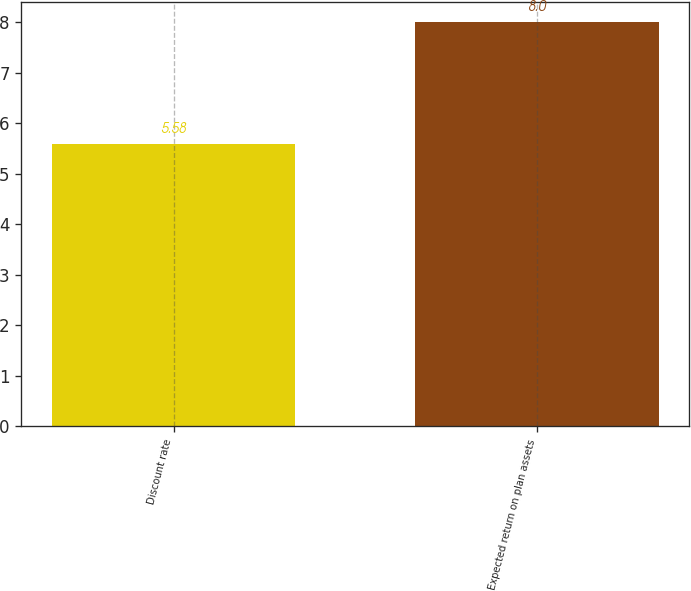<chart> <loc_0><loc_0><loc_500><loc_500><bar_chart><fcel>Discount rate<fcel>Expected return on plan assets<nl><fcel>5.58<fcel>8<nl></chart> 